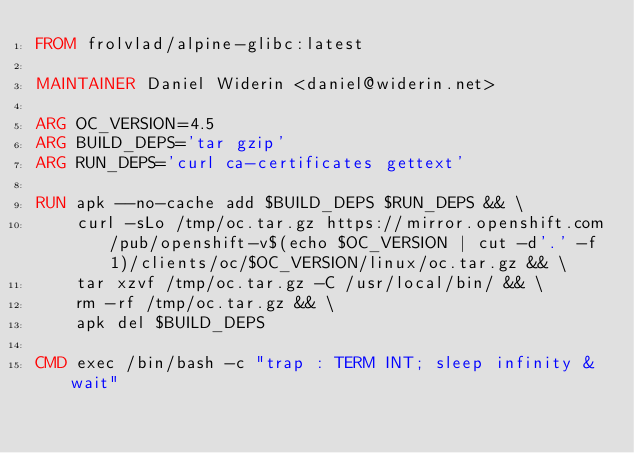<code> <loc_0><loc_0><loc_500><loc_500><_Dockerfile_>FROM frolvlad/alpine-glibc:latest

MAINTAINER Daniel Widerin <daniel@widerin.net>

ARG OC_VERSION=4.5
ARG BUILD_DEPS='tar gzip'
ARG RUN_DEPS='curl ca-certificates gettext'

RUN apk --no-cache add $BUILD_DEPS $RUN_DEPS && \
    curl -sLo /tmp/oc.tar.gz https://mirror.openshift.com/pub/openshift-v$(echo $OC_VERSION | cut -d'.' -f 1)/clients/oc/$OC_VERSION/linux/oc.tar.gz && \
    tar xzvf /tmp/oc.tar.gz -C /usr/local/bin/ && \
    rm -rf /tmp/oc.tar.gz && \
    apk del $BUILD_DEPS

CMD exec /bin/bash -c "trap : TERM INT; sleep infinity & wait"
</code> 